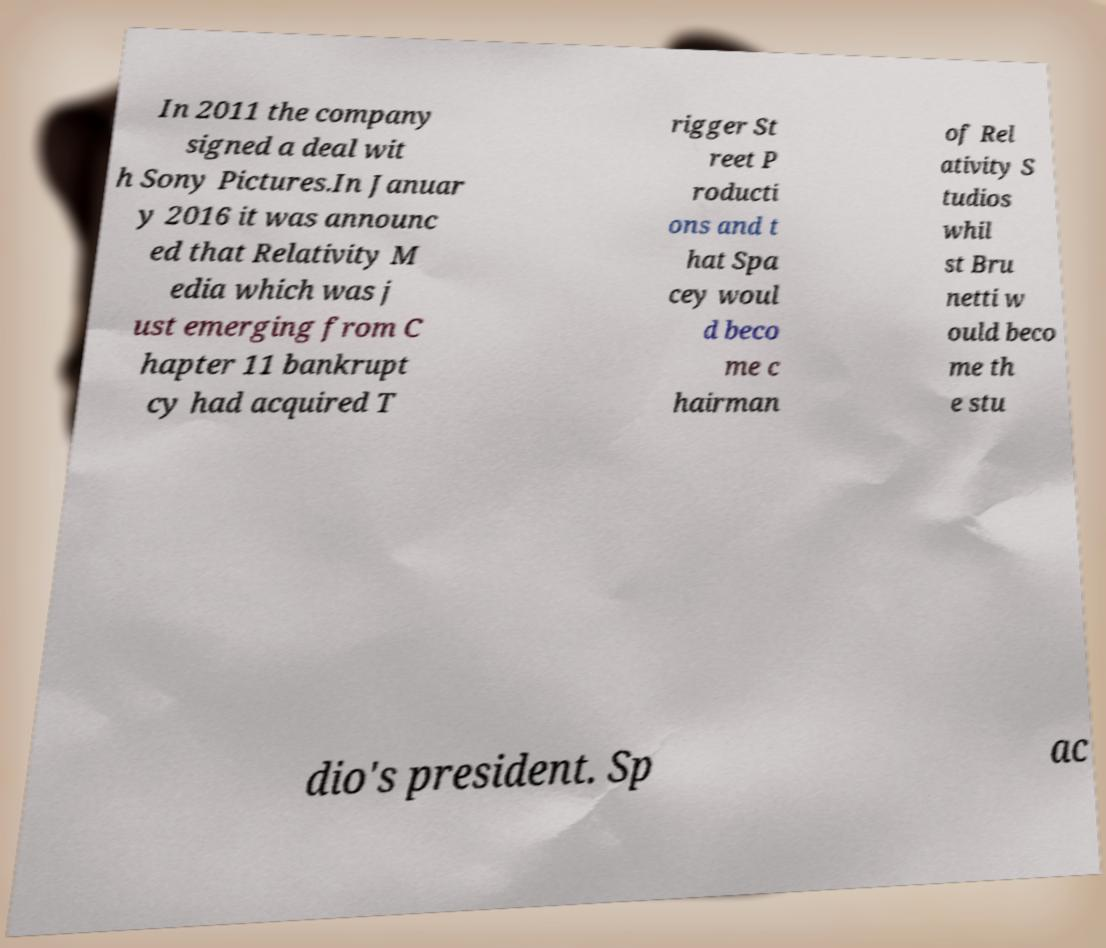Could you extract and type out the text from this image? In 2011 the company signed a deal wit h Sony Pictures.In Januar y 2016 it was announc ed that Relativity M edia which was j ust emerging from C hapter 11 bankrupt cy had acquired T rigger St reet P roducti ons and t hat Spa cey woul d beco me c hairman of Rel ativity S tudios whil st Bru netti w ould beco me th e stu dio's president. Sp ac 